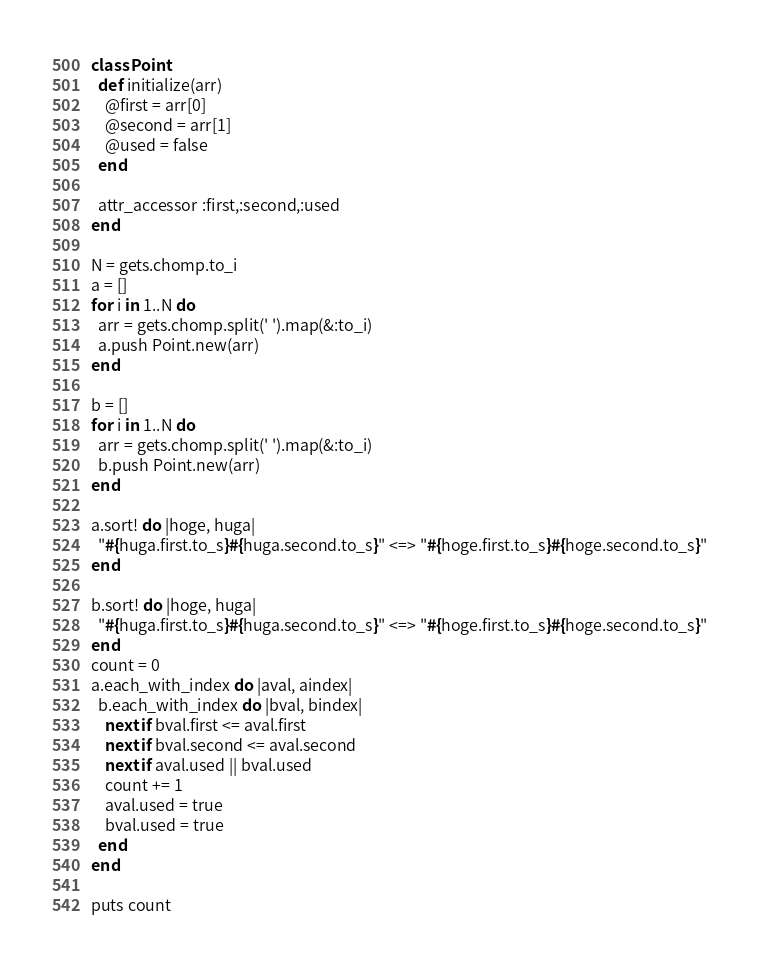<code> <loc_0><loc_0><loc_500><loc_500><_Ruby_>class Point
  def initialize(arr)
    @first = arr[0]
    @second = arr[1]
    @used = false
  end

  attr_accessor :first,:second,:used
end

N = gets.chomp.to_i
a = []
for i in 1..N do
  arr = gets.chomp.split(' ').map(&:to_i)
  a.push Point.new(arr)
end

b = []
for i in 1..N do
  arr = gets.chomp.split(' ').map(&:to_i)
  b.push Point.new(arr)
end

a.sort! do |hoge, huga|
  "#{huga.first.to_s}#{huga.second.to_s}" <=> "#{hoge.first.to_s}#{hoge.second.to_s}"
end

b.sort! do |hoge, huga|
  "#{huga.first.to_s}#{huga.second.to_s}" <=> "#{hoge.first.to_s}#{hoge.second.to_s}"
end
count = 0
a.each_with_index do |aval, aindex|
  b.each_with_index do |bval, bindex|
    next if bval.first <= aval.first
    next if bval.second <= aval.second
    next if aval.used || bval.used
    count += 1
    aval.used = true
    bval.used = true
  end
end

puts count
</code> 